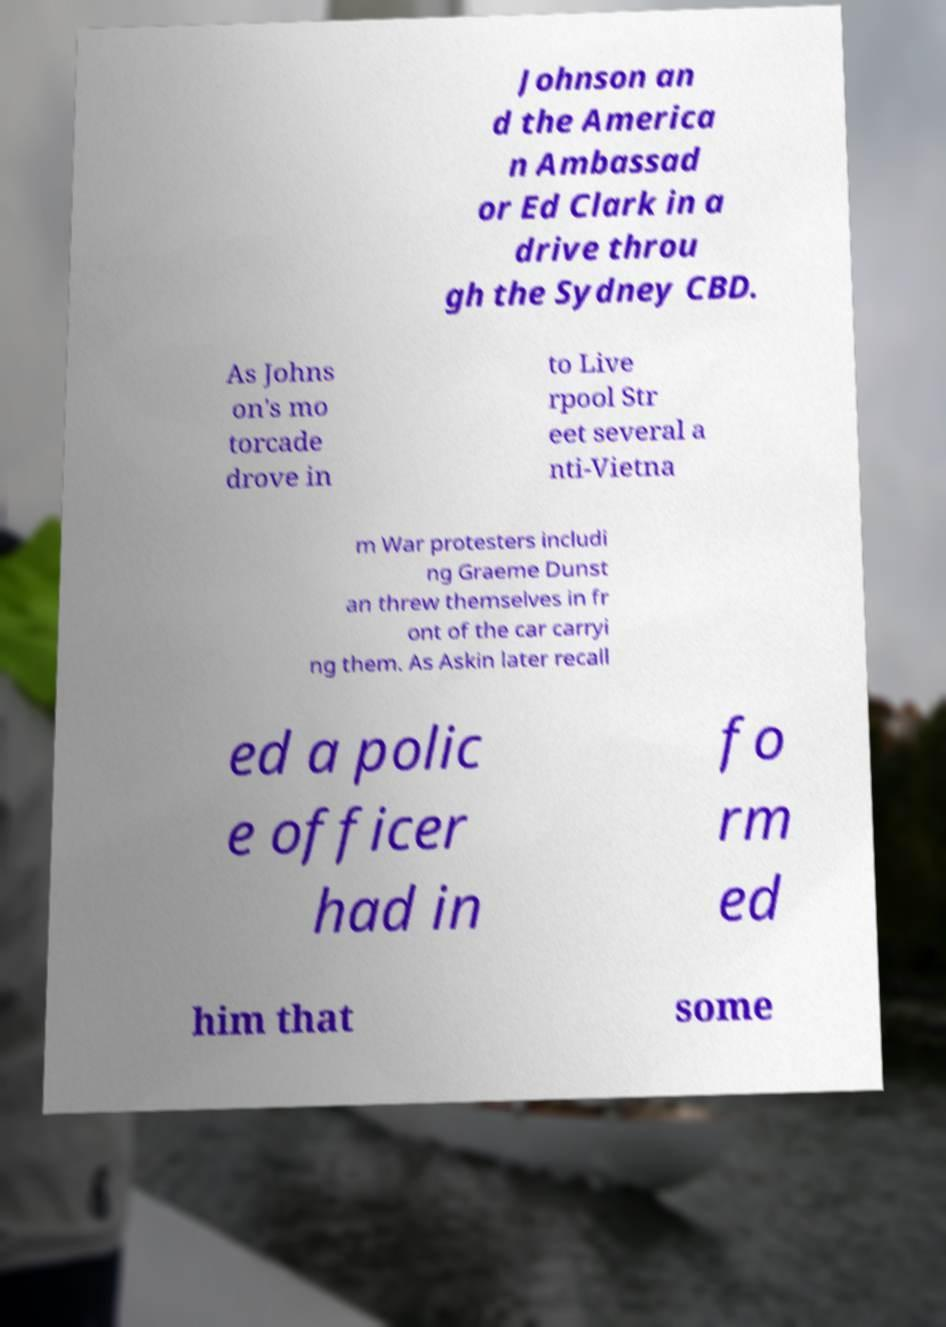Could you assist in decoding the text presented in this image and type it out clearly? Johnson an d the America n Ambassad or Ed Clark in a drive throu gh the Sydney CBD. As Johns on's mo torcade drove in to Live rpool Str eet several a nti-Vietna m War protesters includi ng Graeme Dunst an threw themselves in fr ont of the car carryi ng them. As Askin later recall ed a polic e officer had in fo rm ed him that some 